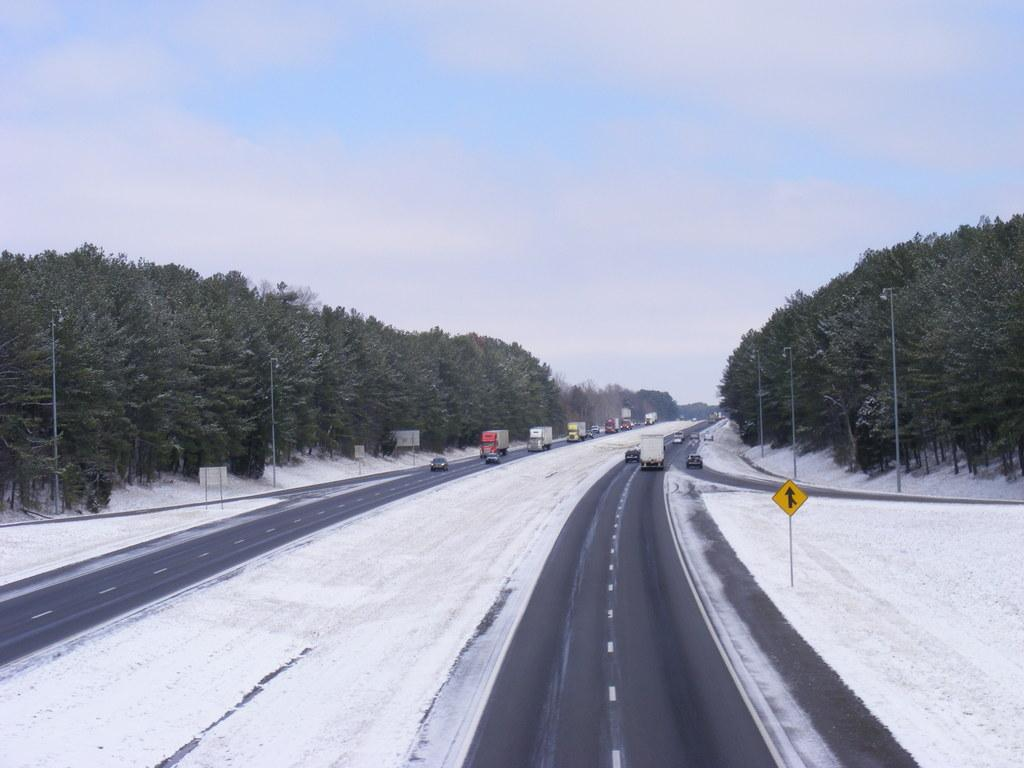What objects can be seen in the foreground of the image? In the foreground of the image, there are sign boards, light poles, a fence, and trees. What is the weather condition in the image? The image shows snow, indicating a cold and wintry condition. What is happening on the road in the image? There are fleets of vehicles on the road, suggesting that it is a busy or active area. What is visible at the top of the image? The sky is visible at the top of the image. What can be inferred about the location of the image? The image appears to be taken on a road. What type of stocking is the tree wearing in the image? There are no stockings present in the image, as trees do not wear clothing. What color is the dress worn by the light pole in the image? Light poles do not wear clothing, so there is no dress present in the image. 